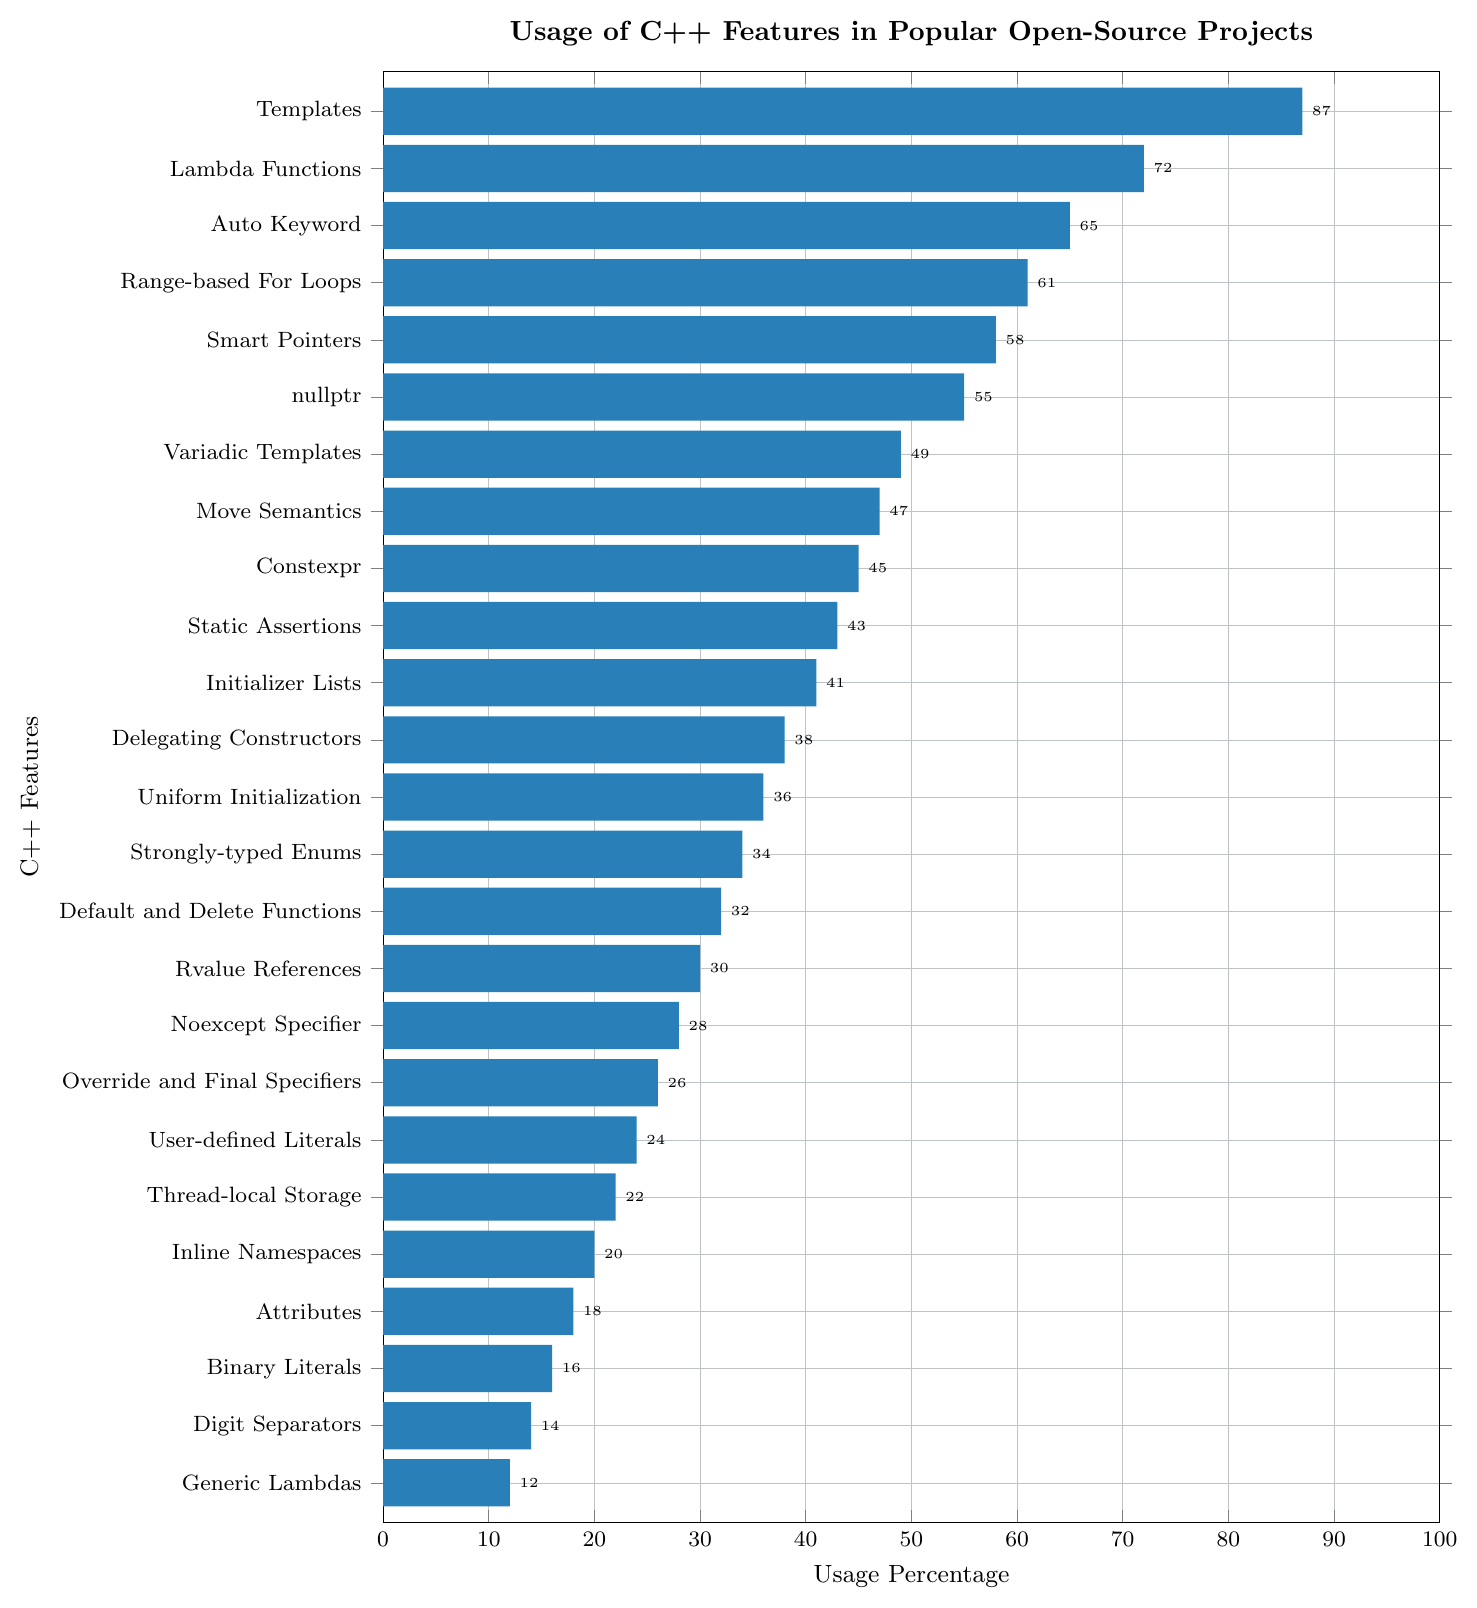Which C++ feature has the highest usage percentage? The bar chart shows various C++ features with their usage percentages. The highest bar length corresponds to 'Templates' with a percentage value of 87%.
Answer: Templates Which feature has a lower usage percentage: Move Semantics or Static Assertions? By comparing the lengths of the bars for 'Move Semantics' and 'Static Assertions', we see that 'Move Semantics' has a usage percentage of 47%, while 'Static Assertions' has 43%. Hence, 'Static Assertions' has a lower usage percentage.
Answer: Static Assertions What is the total usage percentage of 'Lambda Functions', 'nullptr', and 'Auto Keyword'? Adding the usage percentages from the chart: 'Lambda Functions' (72%), 'nullptr' (55%), and 'Auto Keyword' (65%). Therefore, the total is 72+55+65 = 192.
Answer: 192 How many features have a usage percentage greater than 50? By examining the bars, the features with more than 50% usage are 'Templates' (87%), 'Lambda Functions' (72%), 'Auto Keyword' (65%), 'Range-based For Loops' (61%), 'Smart Pointers' (58%), and 'nullptr' (55%). There are 6 such features.
Answer: 6 Which has a higher usage percentage: 'Smart Pointers' or 'Range-based For Loops'? The bar lengths show that 'Smart Pointers' have a usage percentage of 58% while 'Range-based For Loops' have 61%. Hence, 'Range-based For Loops' has a higher percentage.
Answer: Range-based For Loops Which two features have the closest usage percentages and what are their values? By observing the bars, 'Move Semantics' (47%) and 'Constexpr' (45%) have the closest values with a difference of 2%.
Answer: Move Semantics and Constexpr: 47% and 45% What is the average usage percentage of the features 'Smart Pointers', 'Variadic Templates', and 'Range-based For Loops'? Adding their usage percentages: 'Smart Pointers' (58%), 'Variadic Templates' (49%), and 'Range-based For Loops' (61%). The total is 58+49+61 = 168. The average is 168/3 = 56.
Answer: 56 Which feature has the smallest usage percentage? The shortest bar corresponds to 'Generic Lambdas' with a usage percentage of 12%.
Answer: Generic Lambdas What percentage of features have a usage percentage of 40% or higher? Counting the features with a percentage of 40% or greater: 'Templates', 'Lambda Functions', 'Auto Keyword', 'Range-based For Loops', 'Smart Pointers', 'nullptr', 'Variadic Templates', 'Move Semantics', 'Constexpr', 'Static Assertions', and 'Initializer Lists'. That's 11 out of 25 features. The percentage is (11/25)*100 = 44%.
Answer: 44% 